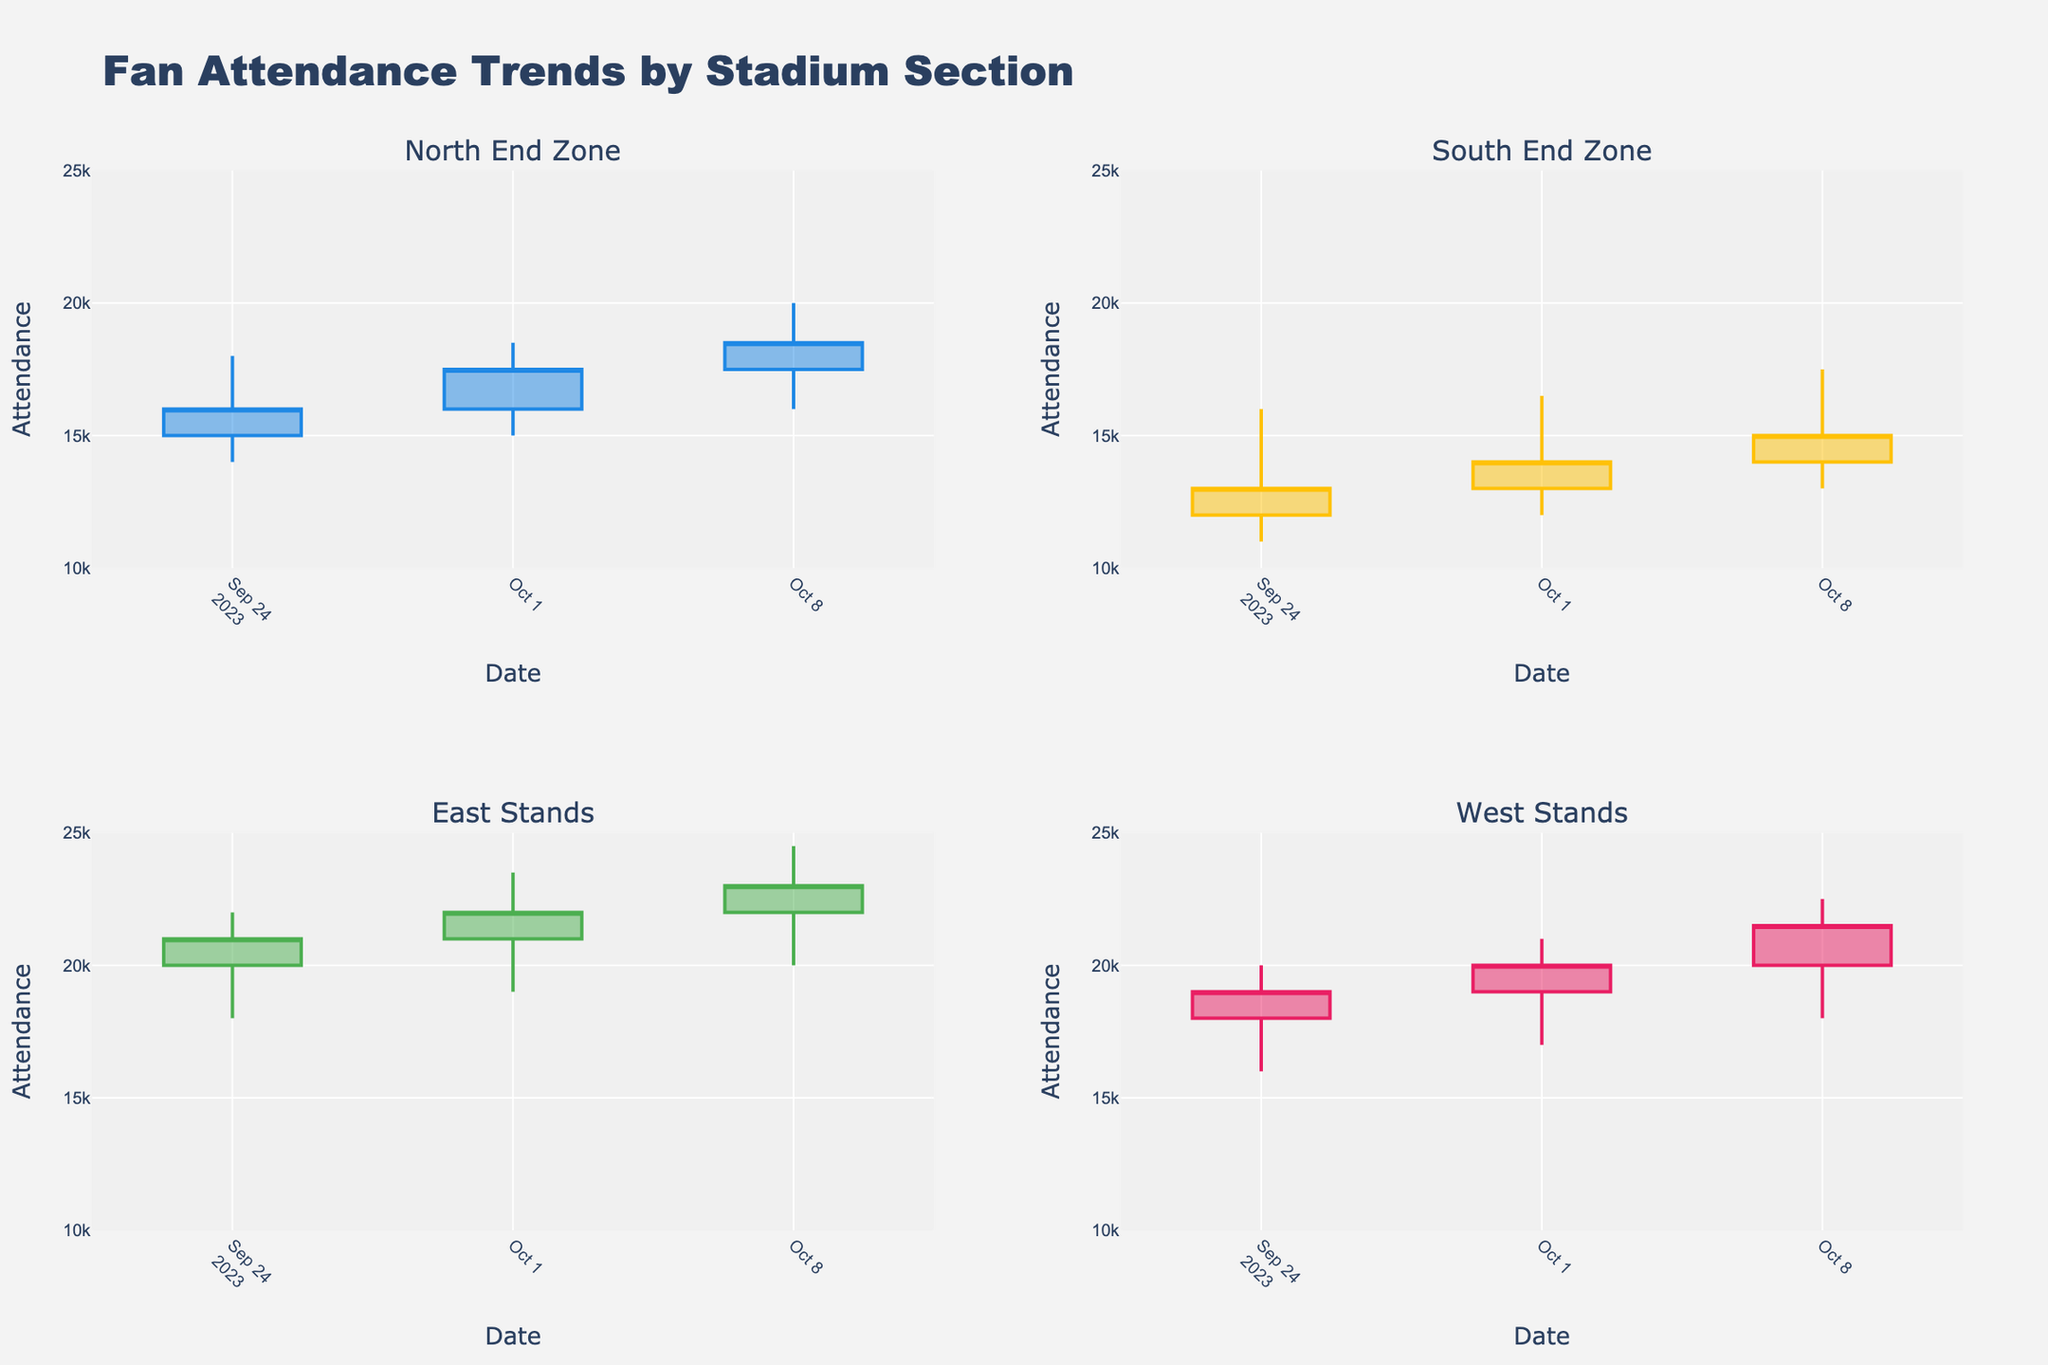Which section had the highest attendance on 2023-09-24? The highest attendance for 2023-09-24 is identified by observing the 'High' values in the candlestick plots; on this date, the East Stands had the highest attendance with a high of 22,000.
Answer: East Stands What is the overall trend for the North End Zone from 2023-09-24 to 2023-10-08? Observing the candlestick plot for the North End Zone, the attendance has shown an increasing trend from 15,000 to 18,500 over the recorded dates.
Answer: Increasing How does the lowest attendance on 2023-10-08 in the South End Zone compare to the lowest attendance on 2023-09-24 in the same section? On 2023-10-08, the lowest attendance in the South End Zone was 13,000, while on 2023-09-24, it was 11,000, indicating a higher minimum attendance in the later date.
Answer: Higher Which section showed the smallest variation in attendance on 2023-10-01? The smallest variation in attendance can be identified by looking at the difference between the 'High' and 'Low' values for each section on 2023-10-01. The West Stands had the smallest variation (21,000 - 17,000 = 4,000).
Answer: West Stands Between the East Stands and West Stands, which section had a higher closing attendance on 2023-09-24? The closing attendance for the East Stands on 2023-09-24 was 21,000, while for the West Stands it was 19,000. Thus, the East Stands had a higher closing attendance.
Answer: East Stands Calculate the average closing attendance in the South End Zone across all dates provided. To calculate the average, sum the closing attendances (13,000 + 14,000 + 15,000 = 42,000) and divide by the number of data points (3), resulting in an average of 14,000.
Answer: 14,000 Which section experienced the highest increase in closing attendance between 2023-09-24 and 2023-10-08? By comparing the closing attendances between these dates for each section, the North End Zone shows the highest increase from 16,000 to 18,500, an increase of 2,500.
Answer: North End Zone What is the range of attendance values for the East Stands on 2023-10-08? The range is determined by the 'High' and 'Low' values for the given date. On 2023-10-08 for the East Stands, the range is from 24,500 to 20,000, a range of 4,500.
Answer: 4,500 How does the attendance trend in the West Stands compare to the other sections over the provided dates? Observing the candlestick plots, the West Stands show a steady and moderate increase in attendance, unlike the other sections which exhibit more dramatic fluctuations in their trends.
Answer: Steadier and moderate increase Which section had the highest volatility in attendance on 2023-09-24, and what was the measure of that volatility? Volatility can be measured by the difference between 'High' and 'Low' values. On 2023-09-24, the highest volatility is seen in the North End Zone, with a difference of (18,000 - 14,000 = 4,000).
Answer: North End Zone 